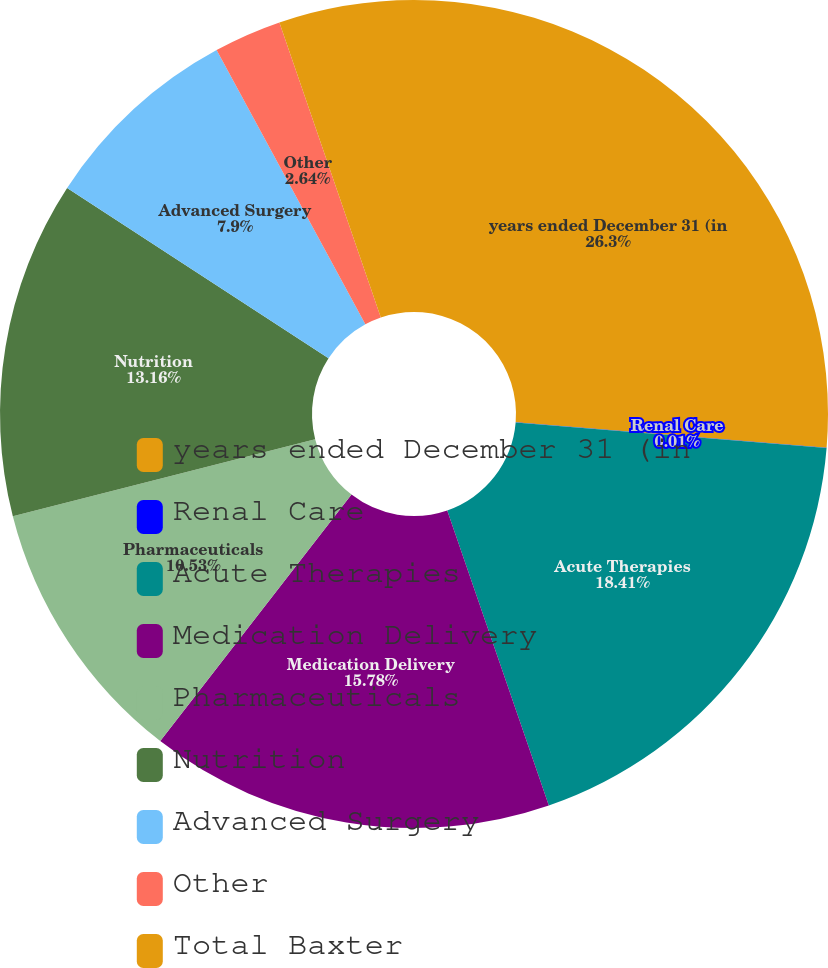<chart> <loc_0><loc_0><loc_500><loc_500><pie_chart><fcel>years ended December 31 (in<fcel>Renal Care<fcel>Acute Therapies<fcel>Medication Delivery<fcel>Pharmaceuticals<fcel>Nutrition<fcel>Advanced Surgery<fcel>Other<fcel>Total Baxter<nl><fcel>26.3%<fcel>0.01%<fcel>18.41%<fcel>15.78%<fcel>10.53%<fcel>13.16%<fcel>7.9%<fcel>2.64%<fcel>5.27%<nl></chart> 